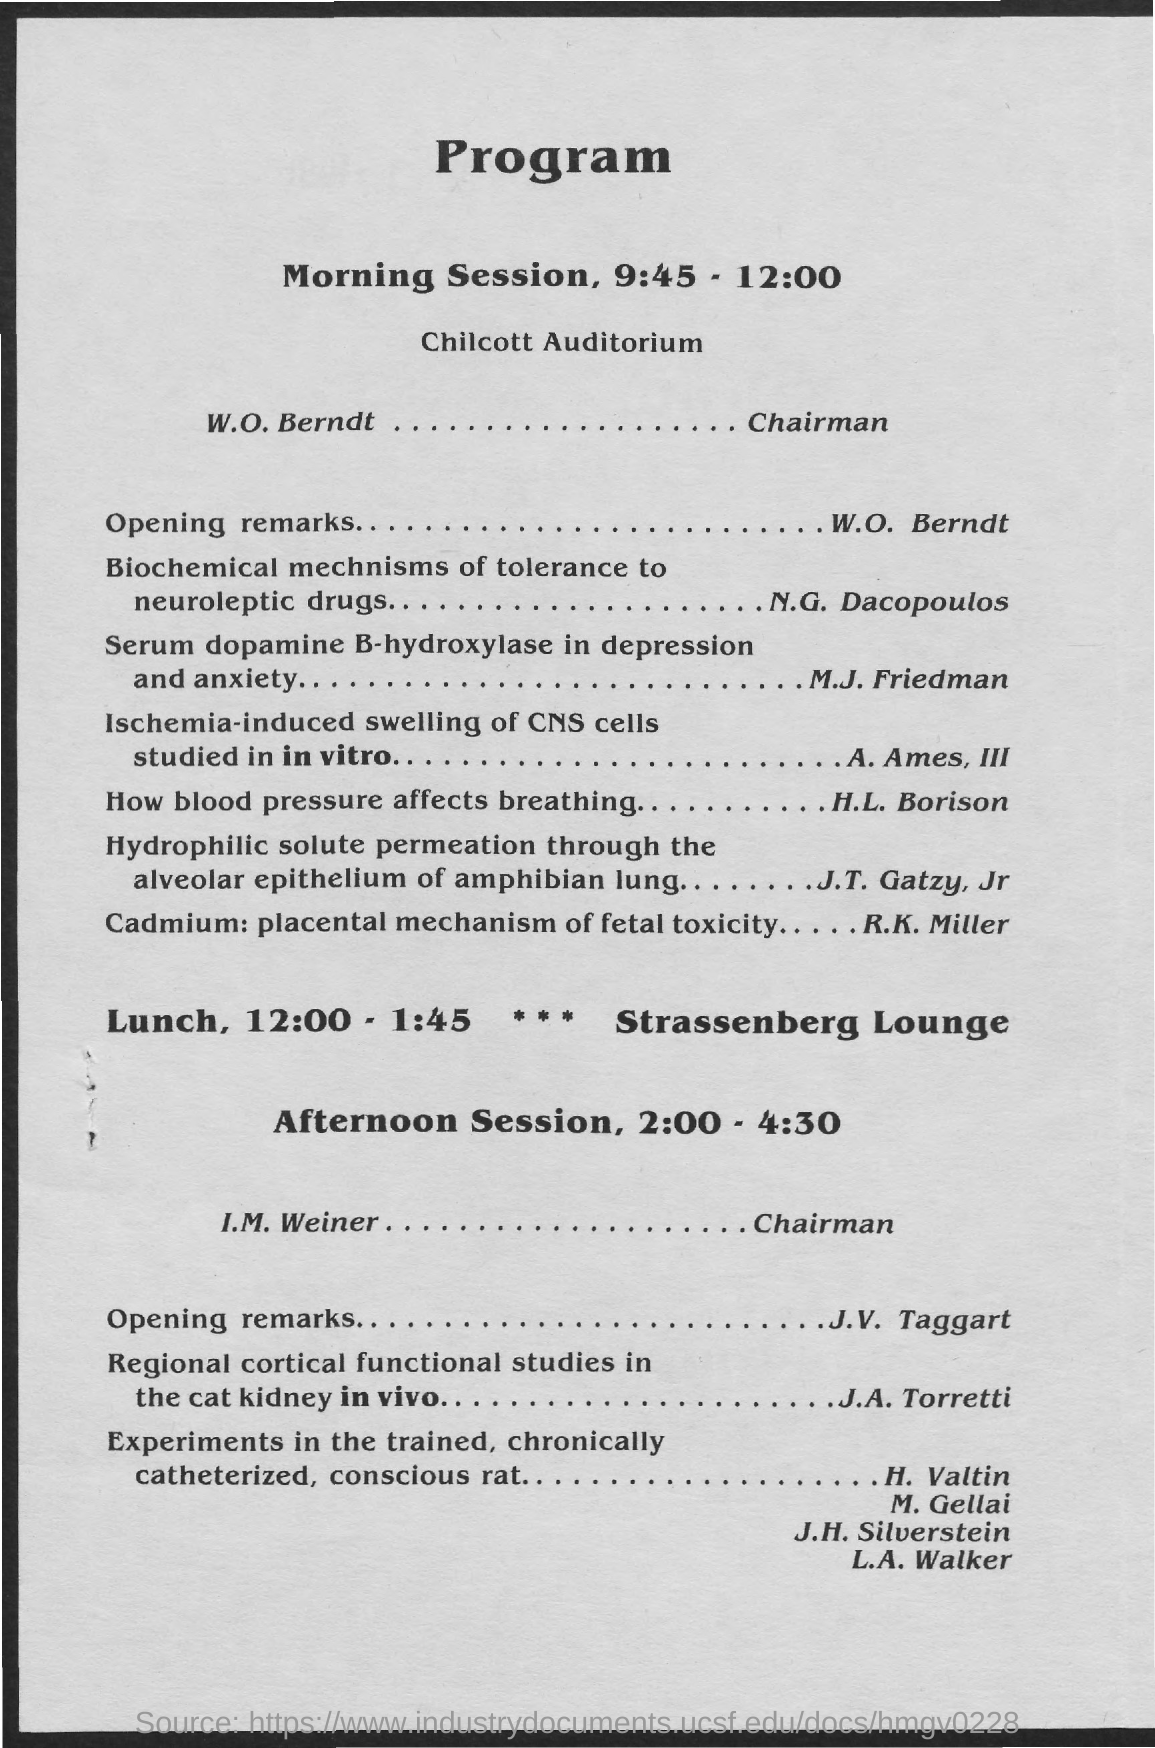What is the heading of the document?
Make the answer very short. Program. What is the timing of the Morning Session?
Keep it short and to the point. 9:45 - 12:00. 